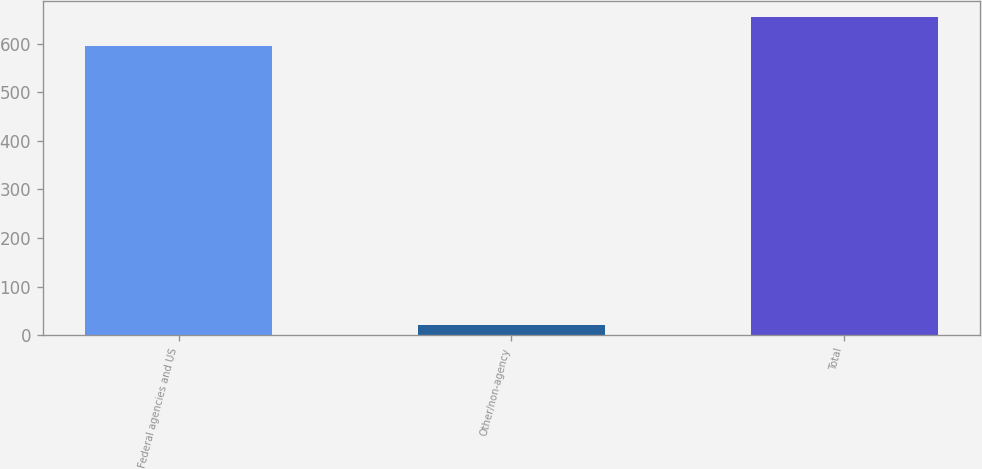<chart> <loc_0><loc_0><loc_500><loc_500><bar_chart><fcel>Federal agencies and US<fcel>Other/non-agency<fcel>Total<nl><fcel>595<fcel>21<fcel>654.5<nl></chart> 